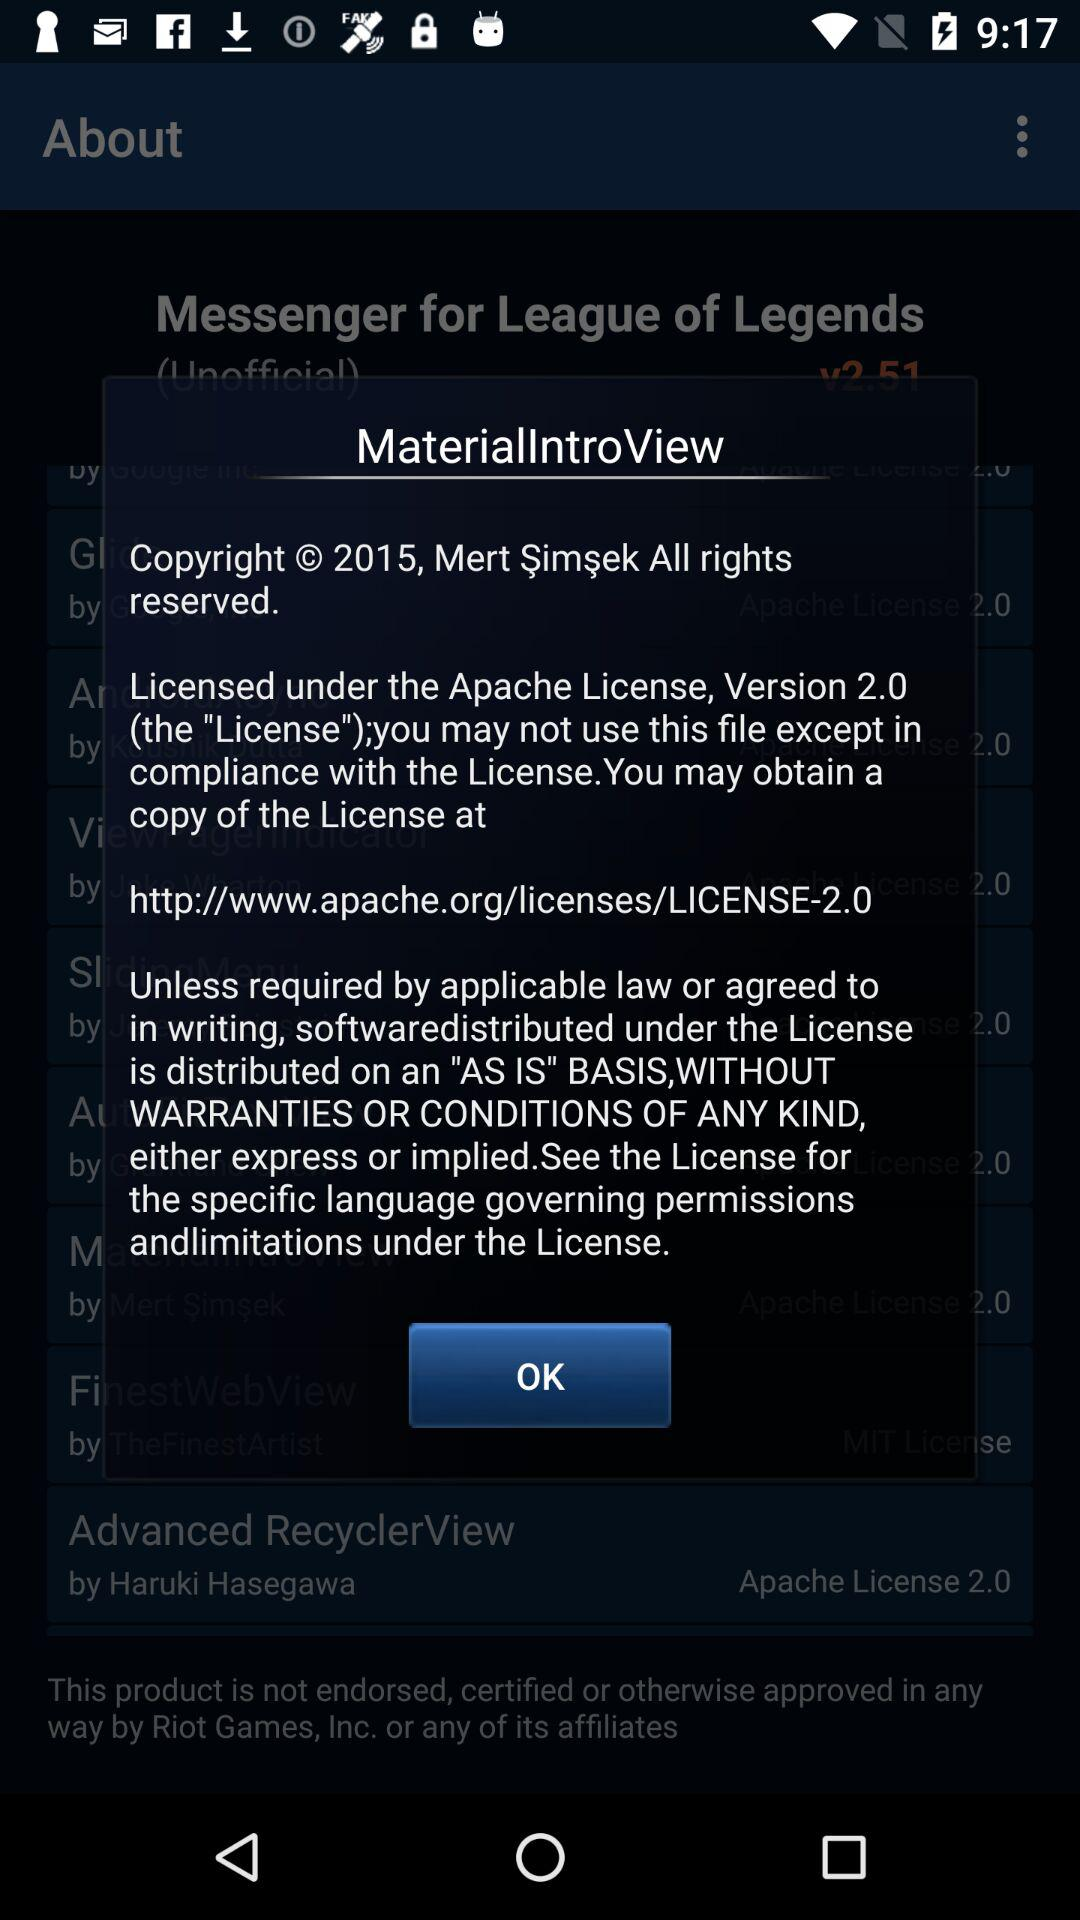What is the link to obtain a copy of the license for the application? The link to obtain a copy of the license for the application is http://www.apache.org/licenses/LICENSE-2.0. 